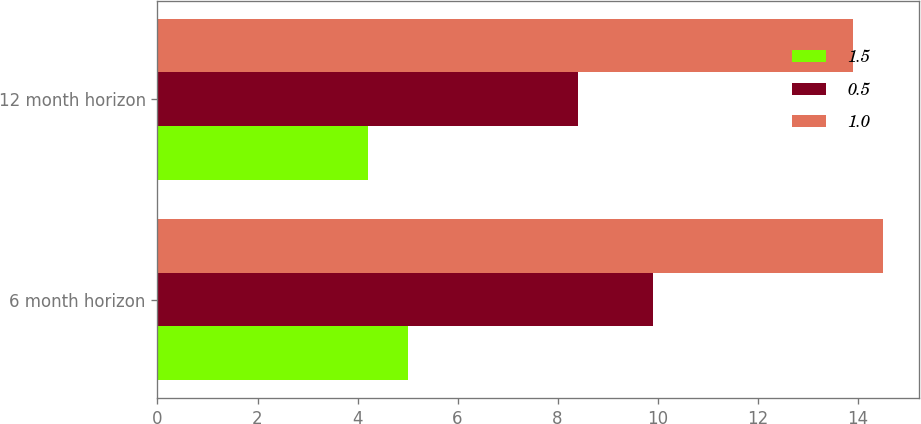Convert chart to OTSL. <chart><loc_0><loc_0><loc_500><loc_500><stacked_bar_chart><ecel><fcel>6 month horizon<fcel>12 month horizon<nl><fcel>1.5<fcel>5<fcel>4.2<nl><fcel>0.5<fcel>9.9<fcel>8.4<nl><fcel>1<fcel>14.5<fcel>13.9<nl></chart> 